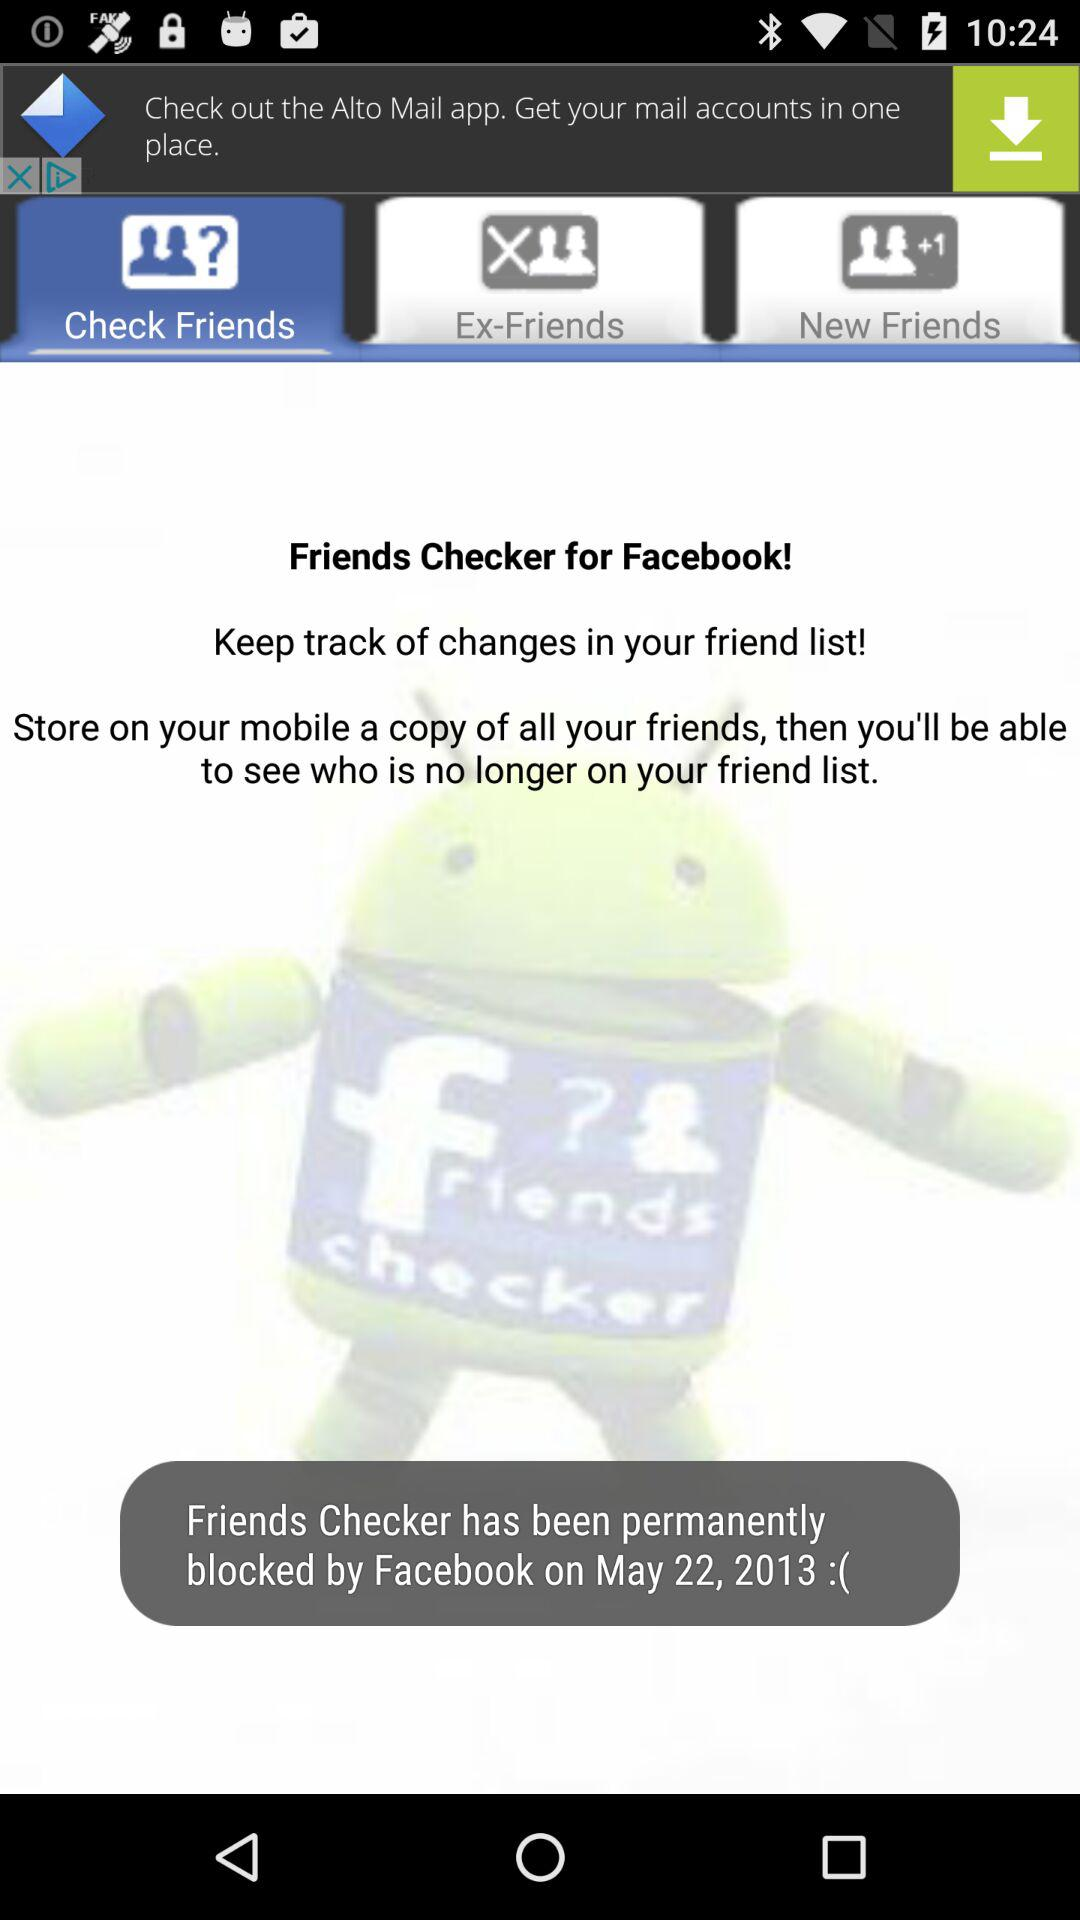What is the selected option? The selected option is "Check Friends". 